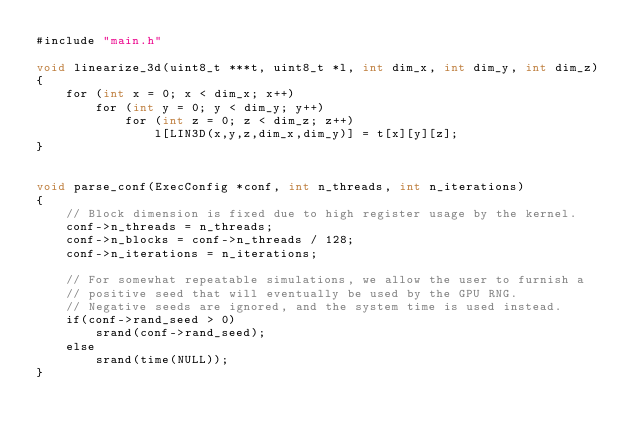Convert code to text. <code><loc_0><loc_0><loc_500><loc_500><_Cuda_>#include "main.h"

void linearize_3d(uint8_t ***t, uint8_t *l, int dim_x, int dim_y, int dim_z)
{
    for (int x = 0; x < dim_x; x++)
        for (int y = 0; y < dim_y; y++)
            for (int z = 0; z < dim_z; z++)
                l[LIN3D(x,y,z,dim_x,dim_y)] = t[x][y][z];
}


void parse_conf(ExecConfig *conf, int n_threads, int n_iterations)
{
    // Block dimension is fixed due to high register usage by the kernel.
    conf->n_threads = n_threads;
    conf->n_blocks = conf->n_threads / 128;
    conf->n_iterations = n_iterations;

    // For somewhat repeatable simulations, we allow the user to furnish a
    // positive seed that will eventually be used by the GPU RNG.
    // Negative seeds are ignored, and the system time is used instead.
    if(conf->rand_seed > 0)
        srand(conf->rand_seed);
    else
        srand(time(NULL));
}
</code> 